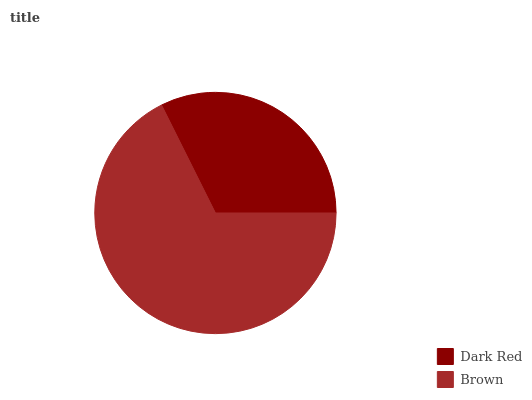Is Dark Red the minimum?
Answer yes or no. Yes. Is Brown the maximum?
Answer yes or no. Yes. Is Brown the minimum?
Answer yes or no. No. Is Brown greater than Dark Red?
Answer yes or no. Yes. Is Dark Red less than Brown?
Answer yes or no. Yes. Is Dark Red greater than Brown?
Answer yes or no. No. Is Brown less than Dark Red?
Answer yes or no. No. Is Brown the high median?
Answer yes or no. Yes. Is Dark Red the low median?
Answer yes or no. Yes. Is Dark Red the high median?
Answer yes or no. No. Is Brown the low median?
Answer yes or no. No. 